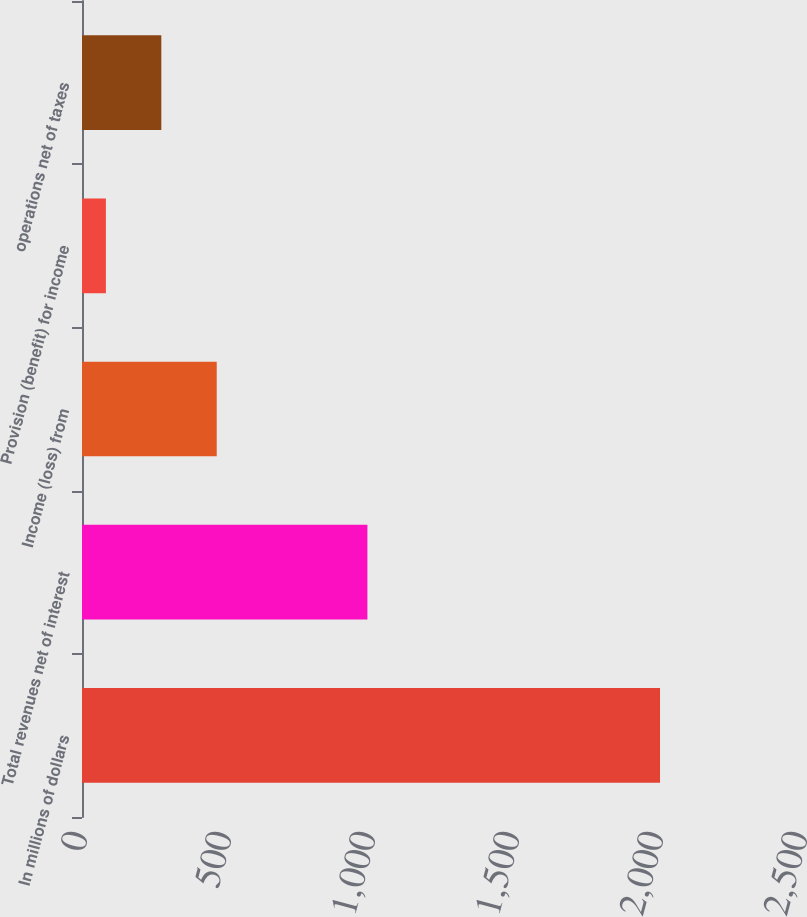Convert chart. <chart><loc_0><loc_0><loc_500><loc_500><bar_chart><fcel>In millions of dollars<fcel>Total revenues net of interest<fcel>Income (loss) from<fcel>Provision (benefit) for income<fcel>operations net of taxes<nl><fcel>2007<fcel>991<fcel>467.8<fcel>83<fcel>275.4<nl></chart> 